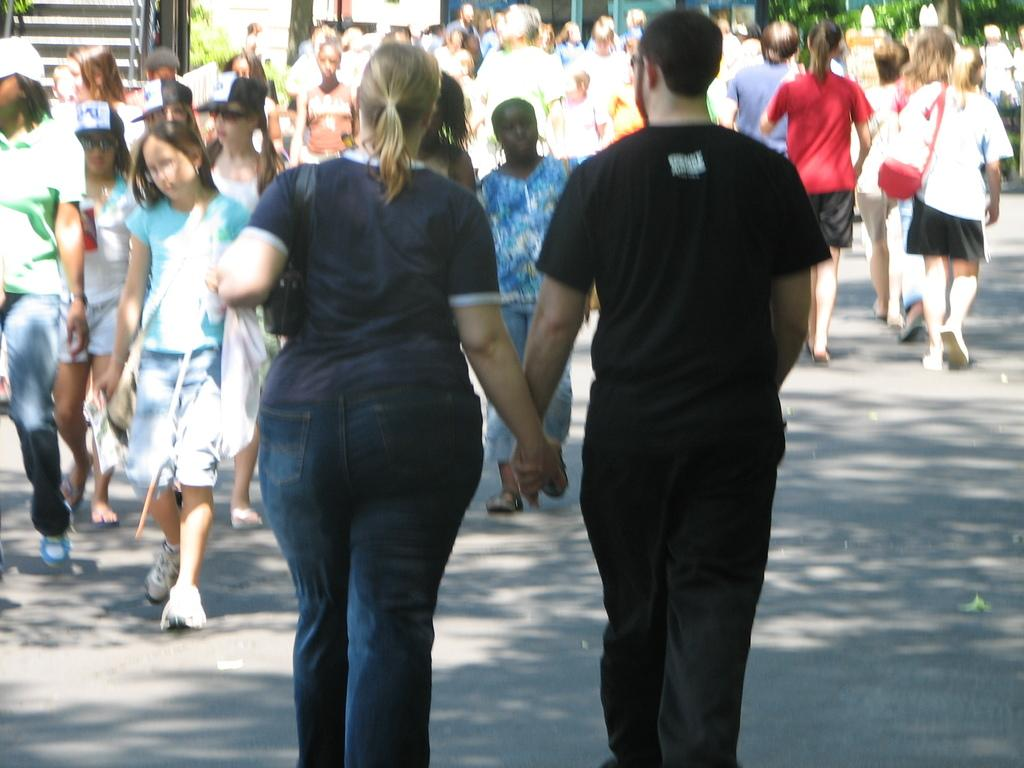What are the people in the image doing? There is a group of people walking on the road in the image. What architectural feature can be seen in the image? There are staircases in the image. What type of vegetation is present in the image? There are trees and plants in the image. What sound does the bat make while flying near the chicken in the image? There is no bat or chicken present in the image, so it is not possible to determine the sound they might make. 